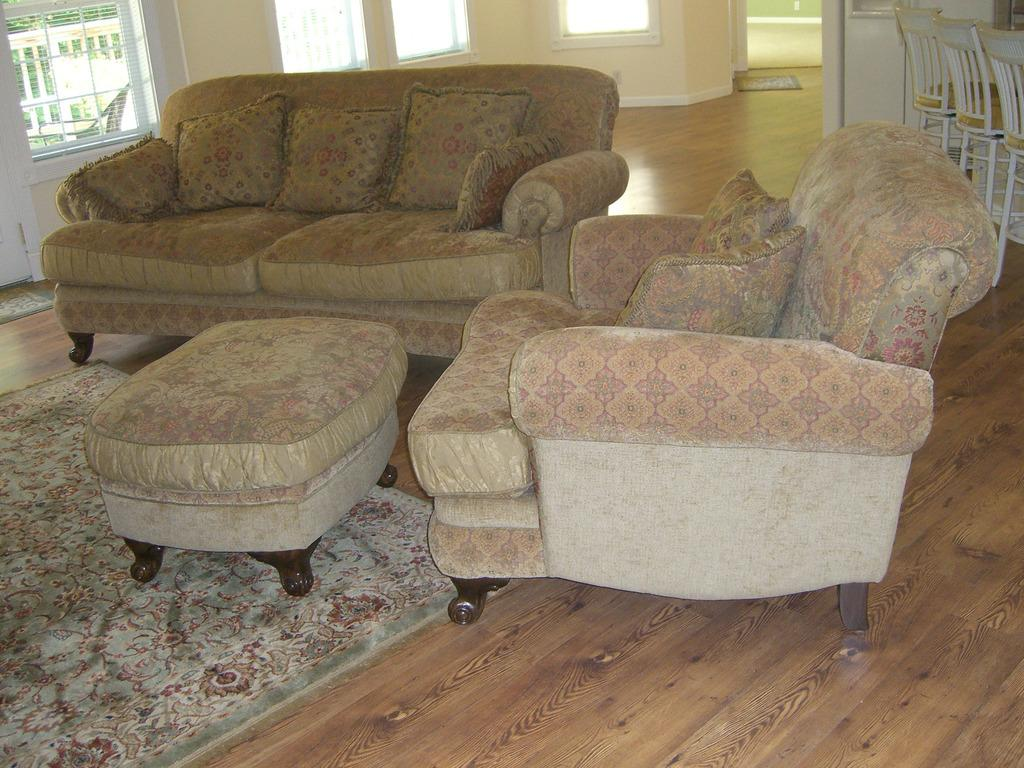What type of space is depicted in the image? There is a room in the image. What type of furniture is present in the room? There are sofas in the room. What can be seen on the sofas? There are pillows on the sofas. What can be seen in the background of the image? There are windows, a door mat, and chairs in the background of the image. How many clams are sitting on the chairs in the background of the image? There are no clams present in the image; it features a room with sofas, pillows, windows, a door mat, and chairs. What type of needle is being used to sew the pillows on the sofas? There is no needle visible in the image, and the pillows are already placed on the sofas. 